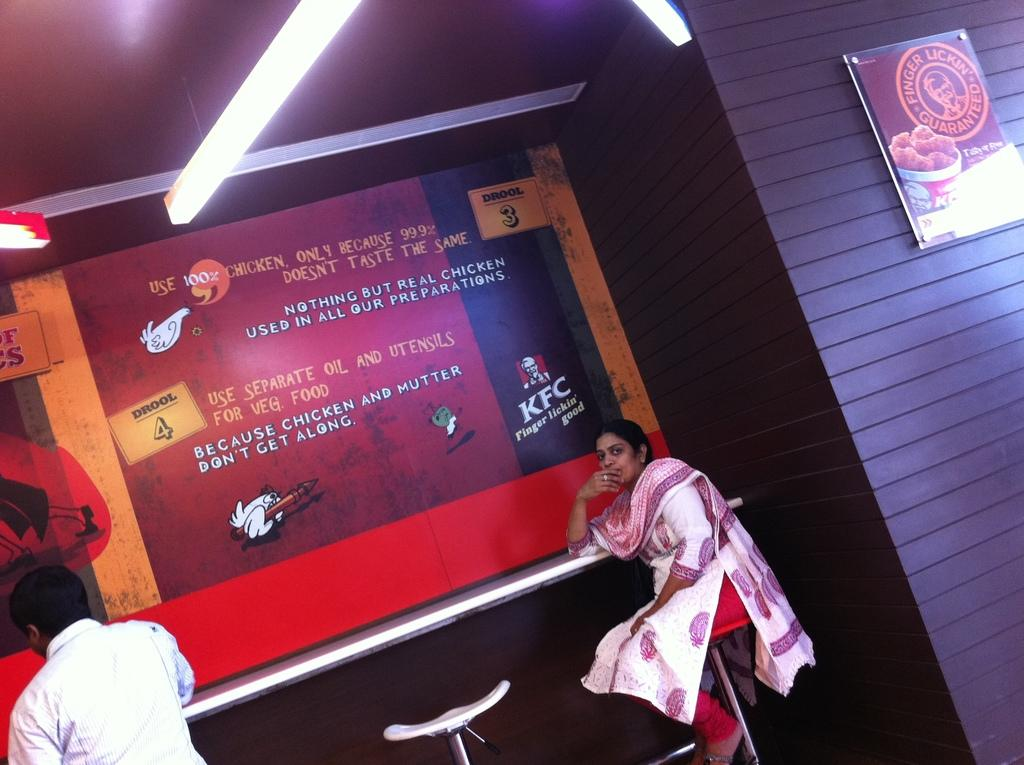<image>
Render a clear and concise summary of the photo. A woman sits at a counter inside a KFC restaurant. 